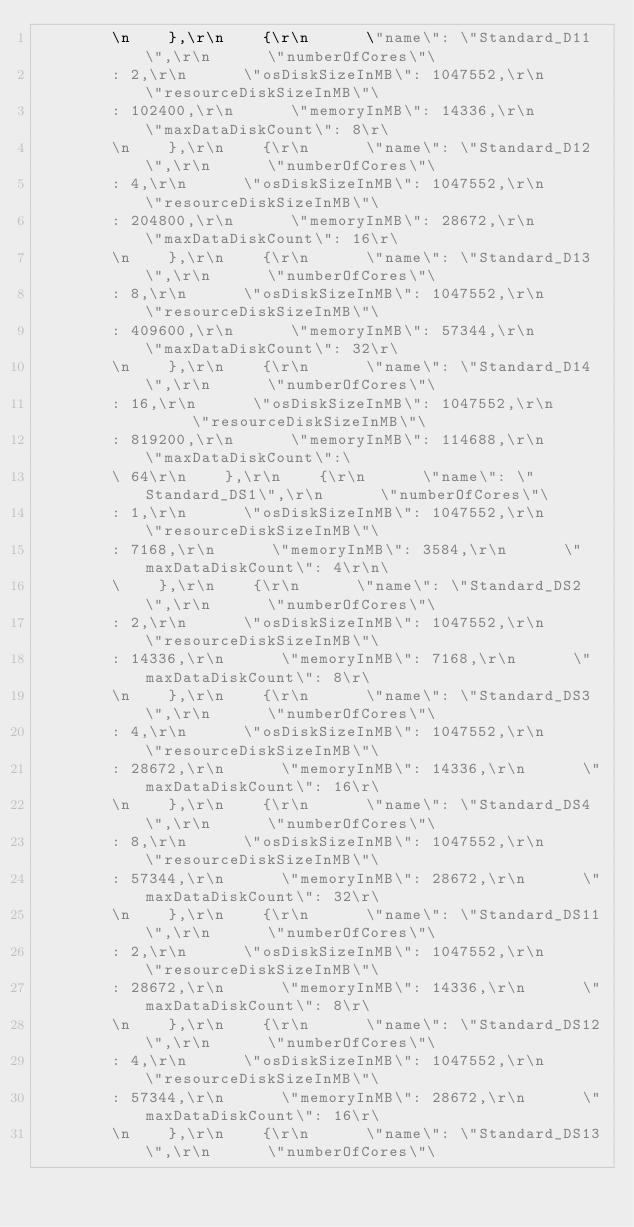<code> <loc_0><loc_0><loc_500><loc_500><_YAML_>        \n    },\r\n    {\r\n      \"name\": \"Standard_D11\",\r\n      \"numberOfCores\"\
        : 2,\r\n      \"osDiskSizeInMB\": 1047552,\r\n      \"resourceDiskSizeInMB\"\
        : 102400,\r\n      \"memoryInMB\": 14336,\r\n      \"maxDataDiskCount\": 8\r\
        \n    },\r\n    {\r\n      \"name\": \"Standard_D12\",\r\n      \"numberOfCores\"\
        : 4,\r\n      \"osDiskSizeInMB\": 1047552,\r\n      \"resourceDiskSizeInMB\"\
        : 204800,\r\n      \"memoryInMB\": 28672,\r\n      \"maxDataDiskCount\": 16\r\
        \n    },\r\n    {\r\n      \"name\": \"Standard_D13\",\r\n      \"numberOfCores\"\
        : 8,\r\n      \"osDiskSizeInMB\": 1047552,\r\n      \"resourceDiskSizeInMB\"\
        : 409600,\r\n      \"memoryInMB\": 57344,\r\n      \"maxDataDiskCount\": 32\r\
        \n    },\r\n    {\r\n      \"name\": \"Standard_D14\",\r\n      \"numberOfCores\"\
        : 16,\r\n      \"osDiskSizeInMB\": 1047552,\r\n      \"resourceDiskSizeInMB\"\
        : 819200,\r\n      \"memoryInMB\": 114688,\r\n      \"maxDataDiskCount\":\
        \ 64\r\n    },\r\n    {\r\n      \"name\": \"Standard_DS1\",\r\n      \"numberOfCores\"\
        : 1,\r\n      \"osDiskSizeInMB\": 1047552,\r\n      \"resourceDiskSizeInMB\"\
        : 7168,\r\n      \"memoryInMB\": 3584,\r\n      \"maxDataDiskCount\": 4\r\n\
        \    },\r\n    {\r\n      \"name\": \"Standard_DS2\",\r\n      \"numberOfCores\"\
        : 2,\r\n      \"osDiskSizeInMB\": 1047552,\r\n      \"resourceDiskSizeInMB\"\
        : 14336,\r\n      \"memoryInMB\": 7168,\r\n      \"maxDataDiskCount\": 8\r\
        \n    },\r\n    {\r\n      \"name\": \"Standard_DS3\",\r\n      \"numberOfCores\"\
        : 4,\r\n      \"osDiskSizeInMB\": 1047552,\r\n      \"resourceDiskSizeInMB\"\
        : 28672,\r\n      \"memoryInMB\": 14336,\r\n      \"maxDataDiskCount\": 16\r\
        \n    },\r\n    {\r\n      \"name\": \"Standard_DS4\",\r\n      \"numberOfCores\"\
        : 8,\r\n      \"osDiskSizeInMB\": 1047552,\r\n      \"resourceDiskSizeInMB\"\
        : 57344,\r\n      \"memoryInMB\": 28672,\r\n      \"maxDataDiskCount\": 32\r\
        \n    },\r\n    {\r\n      \"name\": \"Standard_DS11\",\r\n      \"numberOfCores\"\
        : 2,\r\n      \"osDiskSizeInMB\": 1047552,\r\n      \"resourceDiskSizeInMB\"\
        : 28672,\r\n      \"memoryInMB\": 14336,\r\n      \"maxDataDiskCount\": 8\r\
        \n    },\r\n    {\r\n      \"name\": \"Standard_DS12\",\r\n      \"numberOfCores\"\
        : 4,\r\n      \"osDiskSizeInMB\": 1047552,\r\n      \"resourceDiskSizeInMB\"\
        : 57344,\r\n      \"memoryInMB\": 28672,\r\n      \"maxDataDiskCount\": 16\r\
        \n    },\r\n    {\r\n      \"name\": \"Standard_DS13\",\r\n      \"numberOfCores\"\</code> 